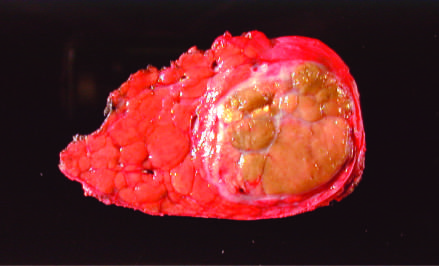what replaced most of the right hepatic lobe in a noncirrhotic liver?
Answer the question using a single word or phrase. Neoplasm 